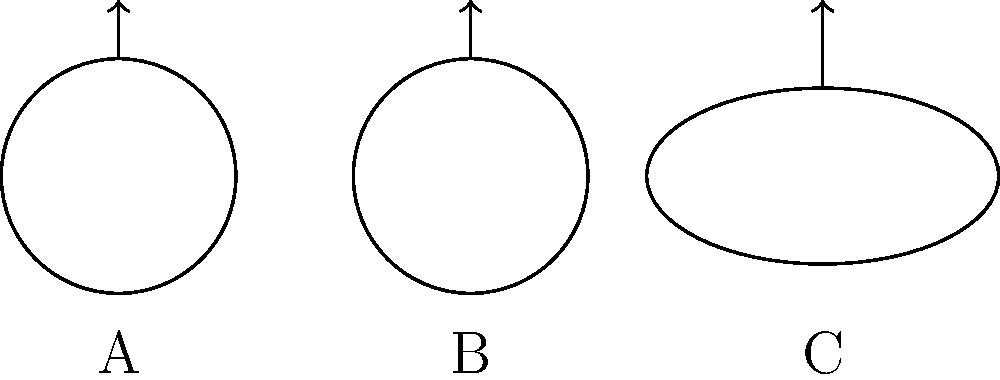Consider the three surfaces shown above: a sphere (A), a torus (B), and a Klein bottle (C). If we were to classify these surfaces based on their genus and number of boundaries, which of these surfaces would be in the same topological class? Explain your reasoning, drawing from concepts that might appear in David Dayen's analyses of complex systems. To answer this question, we need to consider the topological properties of each surface:

1. Sphere (A):
   - Genus: 0 (no holes)
   - Number of boundaries: 0 (closed surface)

2. Torus (B):
   - Genus: 1 (one hole)
   - Number of boundaries: 0 (closed surface)

3. Klein bottle (C):
   - Genus: 1 (equivalent to one hole)
   - Number of boundaries: 0 (closed surface)

The classification of surfaces based on genus and number of boundaries is a fundamental concept in topology. In this context:

- Genus represents the number of "handles" or "holes" in the surface.
- The number of boundaries indicates whether the surface is closed (0 boundaries) or has edges (1 or more boundaries).

Comparing these surfaces:

- The sphere is unique in this group, as it has genus 0.
- Both the torus and Klein bottle have genus 1 and 0 boundaries.

Therefore, the torus (B) and Klein bottle (C) belong to the same topological class.

This classification mirrors David Dayen's approach to analyzing complex systems, where he often looks for underlying structures and connections that may not be immediately apparent. Just as Dayen might uncover hidden relationships in financial or political systems, topology reveals unexpected similarities between seemingly different objects.
Answer: Torus (B) and Klein bottle (C) 